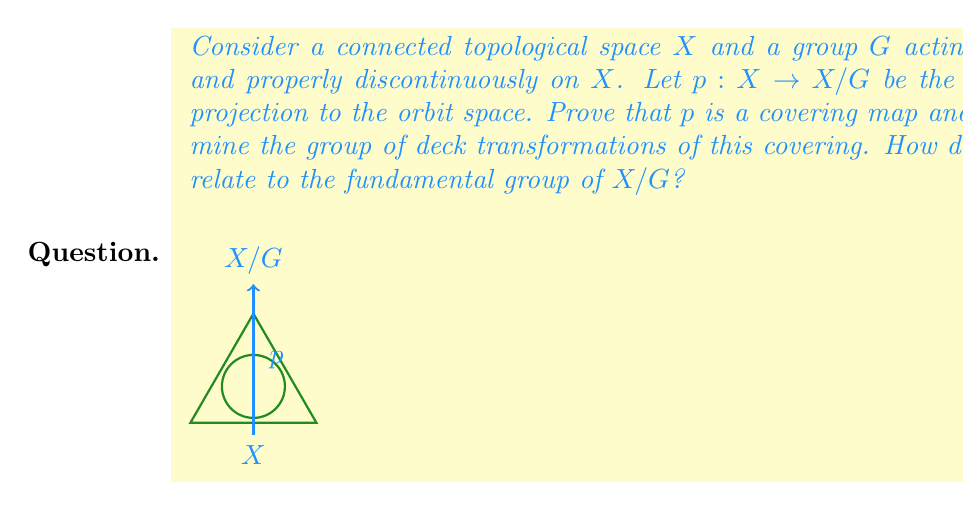Give your solution to this math problem. Let's approach this step-by-step:

1) First, we need to show that $p: X \to X/G$ is a covering map.

   a) For each $[x] \in X/G$, we need to find an open neighborhood $U$ of $[x]$ such that $p^{-1}(U)$ is a disjoint union of open sets in $X$, each homeomorphic to $U$ via $p$.

   b) Since $G$ acts properly discontinuously, for each $x \in X$, there exists an open neighborhood $V_x$ of $x$ such that $gV_x \cap V_x = \emptyset$ for all $g \in G \setminus \{e\}$.

   c) Let $U = p(V_x)$. Then $p^{-1}(U) = \bigcup_{g \in G} gV_x$, which is a disjoint union due to the property of $V_x$.

   d) Each $gV_x$ is homeomorphic to $U$ via $p$ because $G$ acts freely.

2) Now, let's determine the group of deck transformations.

   a) A deck transformation is a homeomorphism $f: X \to X$ such that $p \circ f = p$.

   b) For any $g \in G$, the action of $g$ on $X$ satisfies $p(gx) = p(x)$ for all $x \in X$, so each $g \in G$ defines a deck transformation.

   c) Conversely, if $f$ is a deck transformation, then for any $x \in X$, $p(f(x)) = p(x)$, so $f(x)$ and $x$ are in the same $G$-orbit. Thus, there exists a unique $g \in G$ such that $f(x) = gx$.

   d) Therefore, the group of deck transformations is isomorphic to $G$.

3) Relation to the fundamental group of $X/G$:

   a) If $X$ is simply connected, then by the theory of covering spaces, we have:

      $$\pi_1(X/G) \cong G$$

   b) This is because the group of deck transformations is isomorphic to the quotient of $\pi_1(X/G)$ by $p_*(\pi_1(X))$, where $p_*$ is the induced homomorphism on fundamental groups.

   c) When $X$ is simply connected, $\pi_1(X)$ is trivial, so $\pi_1(X/G)$ is isomorphic to the group of deck transformations, which we showed is isomorphic to $G$.
Answer: $p$ is a covering map; the group of deck transformations is isomorphic to $G$; if $X$ is simply connected, then $\pi_1(X/G) \cong G$. 